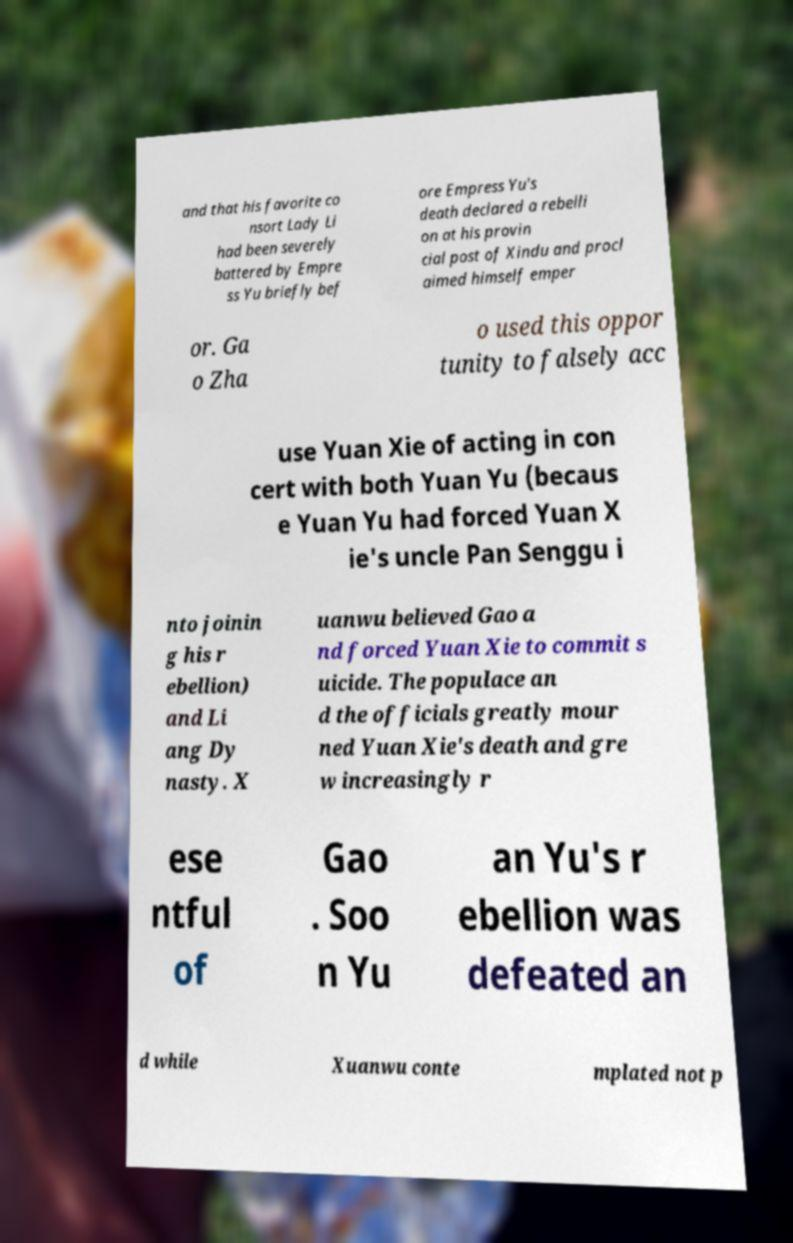I need the written content from this picture converted into text. Can you do that? and that his favorite co nsort Lady Li had been severely battered by Empre ss Yu briefly bef ore Empress Yu's death declared a rebelli on at his provin cial post of Xindu and procl aimed himself emper or. Ga o Zha o used this oppor tunity to falsely acc use Yuan Xie of acting in con cert with both Yuan Yu (becaus e Yuan Yu had forced Yuan X ie's uncle Pan Senggu i nto joinin g his r ebellion) and Li ang Dy nasty. X uanwu believed Gao a nd forced Yuan Xie to commit s uicide. The populace an d the officials greatly mour ned Yuan Xie's death and gre w increasingly r ese ntful of Gao . Soo n Yu an Yu's r ebellion was defeated an d while Xuanwu conte mplated not p 